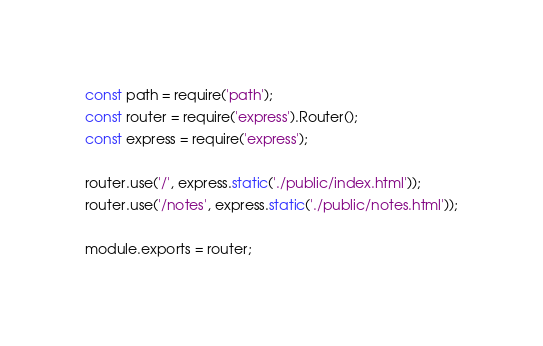<code> <loc_0><loc_0><loc_500><loc_500><_JavaScript_>const path = require('path');
const router = require('express').Router();
const express = require('express');

router.use('/', express.static('./public/index.html'));
router.use('/notes', express.static('./public/notes.html'));

module.exports = router;</code> 